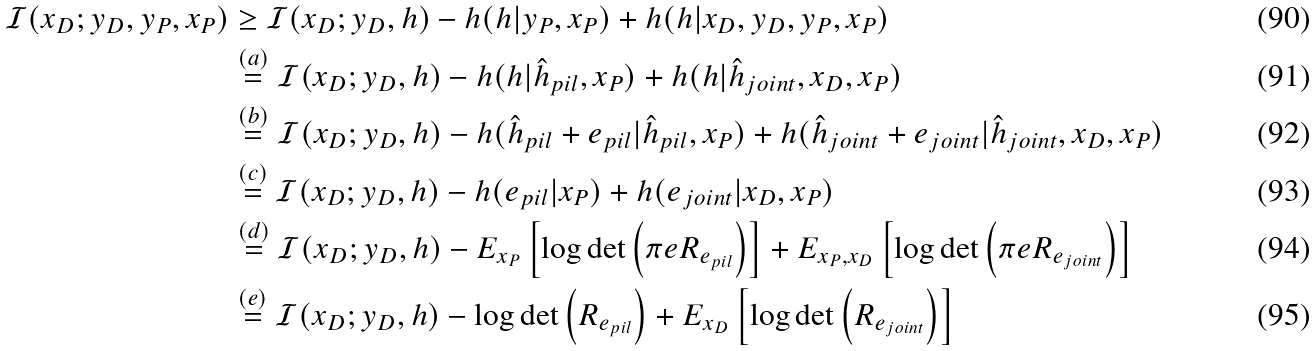<formula> <loc_0><loc_0><loc_500><loc_500>\mathcal { I } ( x _ { D } ; y _ { D } , y _ { P } , x _ { P } ) & \geq \mathcal { I } ( x _ { D } ; y _ { D } , h ) - h ( h | y _ { P } , x _ { P } ) + h ( h | x _ { D } , y _ { D } , y _ { P } , x _ { P } ) \\ & \stackrel { ( a ) } { = } \mathcal { I } ( x _ { D } ; y _ { D } , h ) - h ( h | \hat { h } _ { p i l } , x _ { P } ) + h ( h | \hat { h } _ { j o i n t } , x _ { D } , x _ { P } ) \\ & \stackrel { ( b ) } { = } \mathcal { I } ( x _ { D } ; y _ { D } , h ) - h ( \hat { h } _ { p i l } + e _ { p i l } | \hat { h } _ { p i l } , x _ { P } ) + h ( \hat { h } _ { j o i n t } + e _ { j o i n t } | \hat { h } _ { j o i n t } , x _ { D } , x _ { P } ) \\ & \stackrel { ( c ) } { = } \mathcal { I } ( x _ { D } ; y _ { D } , h ) - h ( e _ { p i l } | x _ { P } ) + h ( e _ { j o i n t } | x _ { D } , x _ { P } ) \\ & \stackrel { ( d ) } { = } \mathcal { I } ( x _ { D } ; y _ { D } , h ) - E _ { x _ { P } } \left [ \log \det \left ( \pi e R _ { e _ { p i l } } \right ) \right ] + E _ { x _ { P } , x _ { D } } \left [ \log \det \left ( \pi e R _ { e _ { j o i n t } } \right ) \right ] \\ & \stackrel { ( e ) } { = } \mathcal { I } ( x _ { D } ; y _ { D } , h ) - \log \det \left ( R _ { e _ { p i l } } \right ) + E _ { x _ { D } } \left [ \log \det \left ( R _ { e _ { j o i n t } } \right ) \right ]</formula> 